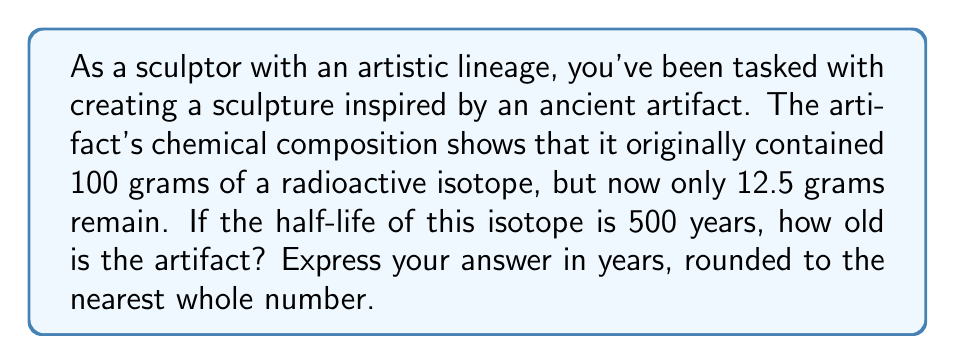Provide a solution to this math problem. Let's approach this problem step-by-step:

1) The decay of radioactive isotopes follows an exponential decay model. The equation for this model is:

   $$A(t) = A_0 \cdot (1/2)^{t/t_{1/2}}$$

   Where:
   $A(t)$ is the amount remaining after time $t$
   $A_0$ is the initial amount
   $t$ is the time elapsed
   $t_{1/2}$ is the half-life

2) We know:
   $A_0 = 100$ grams (initial amount)
   $A(t) = 12.5$ grams (current amount)
   $t_{1/2} = 500$ years (half-life)

3) Let's substitute these values into our equation:

   $$12.5 = 100 \cdot (1/2)^{t/500}$$

4) Divide both sides by 100:

   $$0.125 = (1/2)^{t/500}$$

5) Take the logarithm (base 2) of both sides:

   $$\log_2(0.125) = t/500$$

6) Simplify the left side:

   $$-3 = t/500$$

7) Multiply both sides by 500:

   $$t = -3 \cdot 500 = 1500$$

Therefore, the artifact is approximately 1500 years old.
Answer: 1500 years 